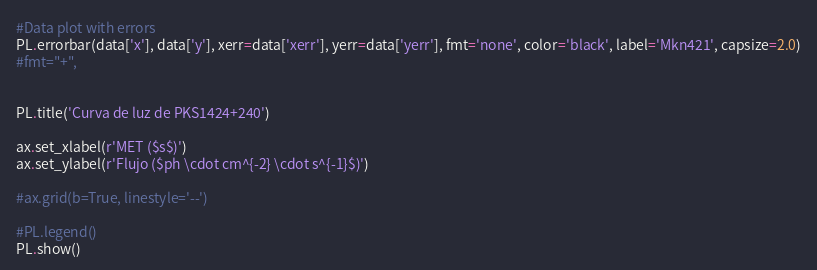Convert code to text. <code><loc_0><loc_0><loc_500><loc_500><_Python_>
#Data plot with errors
PL.errorbar(data['x'], data['y'], xerr=data['xerr'], yerr=data['yerr'], fmt='none', color='black', label='Mkn421', capsize=2.0)
#fmt="+",


PL.title('Curva de luz de PKS1424+240')

ax.set_xlabel(r'MET ($s$)')
ax.set_ylabel(r'Flujo ($ph \cdot cm^{-2} \cdot s^{-1}$)')

#ax.grid(b=True, linestyle='--')

#PL.legend()
PL.show()
</code> 